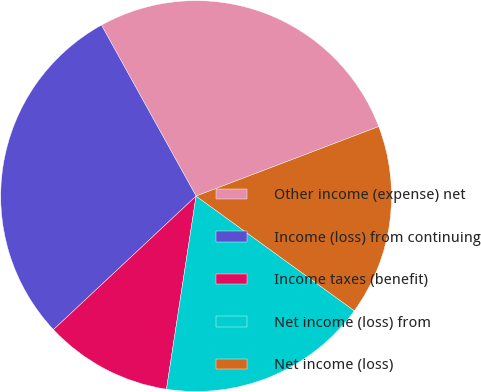Convert chart. <chart><loc_0><loc_0><loc_500><loc_500><pie_chart><fcel>Other income (expense) net<fcel>Income (loss) from continuing<fcel>Income taxes (benefit)<fcel>Net income (loss) from<fcel>Net income (loss)<nl><fcel>27.26%<fcel>28.93%<fcel>10.6%<fcel>17.44%<fcel>15.77%<nl></chart> 